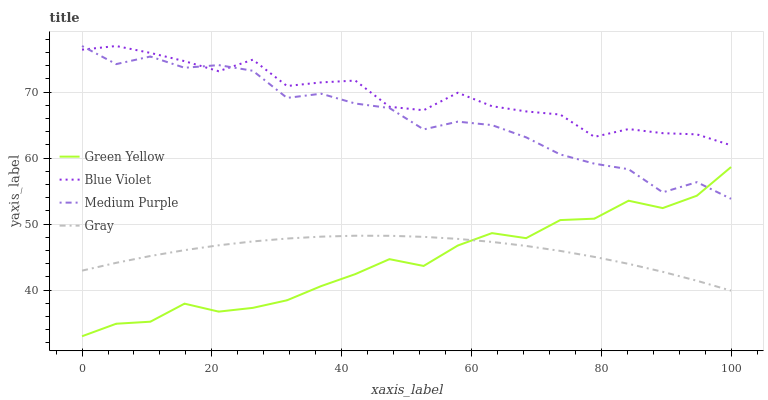Does Green Yellow have the minimum area under the curve?
Answer yes or no. Yes. Does Blue Violet have the maximum area under the curve?
Answer yes or no. Yes. Does Gray have the minimum area under the curve?
Answer yes or no. No. Does Gray have the maximum area under the curve?
Answer yes or no. No. Is Gray the smoothest?
Answer yes or no. Yes. Is Medium Purple the roughest?
Answer yes or no. Yes. Is Green Yellow the smoothest?
Answer yes or no. No. Is Green Yellow the roughest?
Answer yes or no. No. Does Green Yellow have the lowest value?
Answer yes or no. Yes. Does Gray have the lowest value?
Answer yes or no. No. Does Blue Violet have the highest value?
Answer yes or no. Yes. Does Green Yellow have the highest value?
Answer yes or no. No. Is Green Yellow less than Blue Violet?
Answer yes or no. Yes. Is Medium Purple greater than Gray?
Answer yes or no. Yes. Does Medium Purple intersect Green Yellow?
Answer yes or no. Yes. Is Medium Purple less than Green Yellow?
Answer yes or no. No. Is Medium Purple greater than Green Yellow?
Answer yes or no. No. Does Green Yellow intersect Blue Violet?
Answer yes or no. No. 